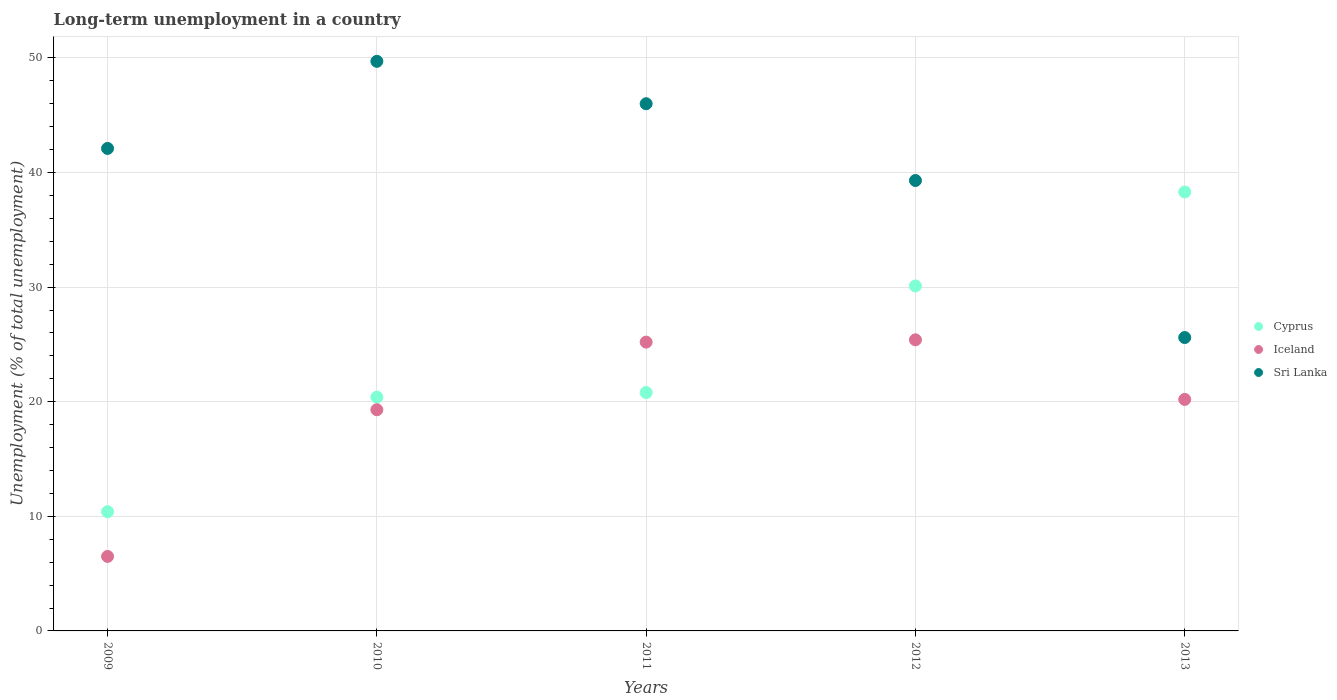What is the percentage of long-term unemployed population in Iceland in 2011?
Offer a very short reply. 25.2. Across all years, what is the maximum percentage of long-term unemployed population in Cyprus?
Make the answer very short. 38.3. Across all years, what is the minimum percentage of long-term unemployed population in Sri Lanka?
Offer a terse response. 25.6. In which year was the percentage of long-term unemployed population in Cyprus minimum?
Offer a very short reply. 2009. What is the total percentage of long-term unemployed population in Cyprus in the graph?
Keep it short and to the point. 120. What is the difference between the percentage of long-term unemployed population in Cyprus in 2010 and that in 2012?
Your answer should be very brief. -9.7. What is the difference between the percentage of long-term unemployed population in Iceland in 2011 and the percentage of long-term unemployed population in Sri Lanka in 2010?
Your answer should be compact. -24.5. What is the average percentage of long-term unemployed population in Sri Lanka per year?
Offer a very short reply. 40.54. In the year 2009, what is the difference between the percentage of long-term unemployed population in Sri Lanka and percentage of long-term unemployed population in Iceland?
Make the answer very short. 35.6. What is the ratio of the percentage of long-term unemployed population in Iceland in 2009 to that in 2012?
Offer a very short reply. 0.26. What is the difference between the highest and the second highest percentage of long-term unemployed population in Sri Lanka?
Keep it short and to the point. 3.7. What is the difference between the highest and the lowest percentage of long-term unemployed population in Sri Lanka?
Provide a succinct answer. 24.1. In how many years, is the percentage of long-term unemployed population in Cyprus greater than the average percentage of long-term unemployed population in Cyprus taken over all years?
Offer a very short reply. 2. Is it the case that in every year, the sum of the percentage of long-term unemployed population in Sri Lanka and percentage of long-term unemployed population in Iceland  is greater than the percentage of long-term unemployed population in Cyprus?
Your response must be concise. Yes. Does the percentage of long-term unemployed population in Cyprus monotonically increase over the years?
Ensure brevity in your answer.  Yes. How many dotlines are there?
Offer a terse response. 3. How many years are there in the graph?
Offer a terse response. 5. Are the values on the major ticks of Y-axis written in scientific E-notation?
Your answer should be very brief. No. Does the graph contain any zero values?
Provide a succinct answer. No. What is the title of the graph?
Your answer should be very brief. Long-term unemployment in a country. Does "Antigua and Barbuda" appear as one of the legend labels in the graph?
Provide a succinct answer. No. What is the label or title of the X-axis?
Offer a terse response. Years. What is the label or title of the Y-axis?
Ensure brevity in your answer.  Unemployment (% of total unemployment). What is the Unemployment (% of total unemployment) in Cyprus in 2009?
Offer a very short reply. 10.4. What is the Unemployment (% of total unemployment) of Sri Lanka in 2009?
Offer a very short reply. 42.1. What is the Unemployment (% of total unemployment) of Cyprus in 2010?
Ensure brevity in your answer.  20.4. What is the Unemployment (% of total unemployment) of Iceland in 2010?
Offer a terse response. 19.3. What is the Unemployment (% of total unemployment) of Sri Lanka in 2010?
Keep it short and to the point. 49.7. What is the Unemployment (% of total unemployment) in Cyprus in 2011?
Your response must be concise. 20.8. What is the Unemployment (% of total unemployment) in Iceland in 2011?
Provide a short and direct response. 25.2. What is the Unemployment (% of total unemployment) of Cyprus in 2012?
Give a very brief answer. 30.1. What is the Unemployment (% of total unemployment) of Iceland in 2012?
Keep it short and to the point. 25.4. What is the Unemployment (% of total unemployment) of Sri Lanka in 2012?
Your answer should be compact. 39.3. What is the Unemployment (% of total unemployment) of Cyprus in 2013?
Ensure brevity in your answer.  38.3. What is the Unemployment (% of total unemployment) in Iceland in 2013?
Your answer should be very brief. 20.2. What is the Unemployment (% of total unemployment) in Sri Lanka in 2013?
Your answer should be very brief. 25.6. Across all years, what is the maximum Unemployment (% of total unemployment) of Cyprus?
Ensure brevity in your answer.  38.3. Across all years, what is the maximum Unemployment (% of total unemployment) in Iceland?
Provide a short and direct response. 25.4. Across all years, what is the maximum Unemployment (% of total unemployment) in Sri Lanka?
Make the answer very short. 49.7. Across all years, what is the minimum Unemployment (% of total unemployment) of Cyprus?
Your answer should be compact. 10.4. Across all years, what is the minimum Unemployment (% of total unemployment) of Sri Lanka?
Your answer should be very brief. 25.6. What is the total Unemployment (% of total unemployment) of Cyprus in the graph?
Your response must be concise. 120. What is the total Unemployment (% of total unemployment) in Iceland in the graph?
Your answer should be compact. 96.6. What is the total Unemployment (% of total unemployment) in Sri Lanka in the graph?
Give a very brief answer. 202.7. What is the difference between the Unemployment (% of total unemployment) in Cyprus in 2009 and that in 2010?
Keep it short and to the point. -10. What is the difference between the Unemployment (% of total unemployment) of Iceland in 2009 and that in 2010?
Give a very brief answer. -12.8. What is the difference between the Unemployment (% of total unemployment) of Sri Lanka in 2009 and that in 2010?
Ensure brevity in your answer.  -7.6. What is the difference between the Unemployment (% of total unemployment) in Iceland in 2009 and that in 2011?
Your response must be concise. -18.7. What is the difference between the Unemployment (% of total unemployment) of Sri Lanka in 2009 and that in 2011?
Your answer should be very brief. -3.9. What is the difference between the Unemployment (% of total unemployment) in Cyprus in 2009 and that in 2012?
Make the answer very short. -19.7. What is the difference between the Unemployment (% of total unemployment) in Iceland in 2009 and that in 2012?
Offer a terse response. -18.9. What is the difference between the Unemployment (% of total unemployment) in Cyprus in 2009 and that in 2013?
Offer a very short reply. -27.9. What is the difference between the Unemployment (% of total unemployment) in Iceland in 2009 and that in 2013?
Offer a terse response. -13.7. What is the difference between the Unemployment (% of total unemployment) in Cyprus in 2010 and that in 2012?
Provide a succinct answer. -9.7. What is the difference between the Unemployment (% of total unemployment) in Iceland in 2010 and that in 2012?
Your response must be concise. -6.1. What is the difference between the Unemployment (% of total unemployment) of Sri Lanka in 2010 and that in 2012?
Give a very brief answer. 10.4. What is the difference between the Unemployment (% of total unemployment) in Cyprus in 2010 and that in 2013?
Keep it short and to the point. -17.9. What is the difference between the Unemployment (% of total unemployment) of Iceland in 2010 and that in 2013?
Provide a succinct answer. -0.9. What is the difference between the Unemployment (% of total unemployment) of Sri Lanka in 2010 and that in 2013?
Your answer should be compact. 24.1. What is the difference between the Unemployment (% of total unemployment) in Cyprus in 2011 and that in 2012?
Give a very brief answer. -9.3. What is the difference between the Unemployment (% of total unemployment) in Cyprus in 2011 and that in 2013?
Keep it short and to the point. -17.5. What is the difference between the Unemployment (% of total unemployment) in Iceland in 2011 and that in 2013?
Provide a short and direct response. 5. What is the difference between the Unemployment (% of total unemployment) of Sri Lanka in 2011 and that in 2013?
Your answer should be very brief. 20.4. What is the difference between the Unemployment (% of total unemployment) of Cyprus in 2012 and that in 2013?
Provide a succinct answer. -8.2. What is the difference between the Unemployment (% of total unemployment) in Iceland in 2012 and that in 2013?
Provide a short and direct response. 5.2. What is the difference between the Unemployment (% of total unemployment) of Cyprus in 2009 and the Unemployment (% of total unemployment) of Sri Lanka in 2010?
Offer a terse response. -39.3. What is the difference between the Unemployment (% of total unemployment) of Iceland in 2009 and the Unemployment (% of total unemployment) of Sri Lanka in 2010?
Provide a succinct answer. -43.2. What is the difference between the Unemployment (% of total unemployment) of Cyprus in 2009 and the Unemployment (% of total unemployment) of Iceland in 2011?
Provide a short and direct response. -14.8. What is the difference between the Unemployment (% of total unemployment) in Cyprus in 2009 and the Unemployment (% of total unemployment) in Sri Lanka in 2011?
Your response must be concise. -35.6. What is the difference between the Unemployment (% of total unemployment) in Iceland in 2009 and the Unemployment (% of total unemployment) in Sri Lanka in 2011?
Make the answer very short. -39.5. What is the difference between the Unemployment (% of total unemployment) in Cyprus in 2009 and the Unemployment (% of total unemployment) in Iceland in 2012?
Keep it short and to the point. -15. What is the difference between the Unemployment (% of total unemployment) in Cyprus in 2009 and the Unemployment (% of total unemployment) in Sri Lanka in 2012?
Your answer should be very brief. -28.9. What is the difference between the Unemployment (% of total unemployment) of Iceland in 2009 and the Unemployment (% of total unemployment) of Sri Lanka in 2012?
Make the answer very short. -32.8. What is the difference between the Unemployment (% of total unemployment) in Cyprus in 2009 and the Unemployment (% of total unemployment) in Sri Lanka in 2013?
Provide a short and direct response. -15.2. What is the difference between the Unemployment (% of total unemployment) of Iceland in 2009 and the Unemployment (% of total unemployment) of Sri Lanka in 2013?
Make the answer very short. -19.1. What is the difference between the Unemployment (% of total unemployment) in Cyprus in 2010 and the Unemployment (% of total unemployment) in Iceland in 2011?
Your answer should be very brief. -4.8. What is the difference between the Unemployment (% of total unemployment) in Cyprus in 2010 and the Unemployment (% of total unemployment) in Sri Lanka in 2011?
Your response must be concise. -25.6. What is the difference between the Unemployment (% of total unemployment) in Iceland in 2010 and the Unemployment (% of total unemployment) in Sri Lanka in 2011?
Provide a short and direct response. -26.7. What is the difference between the Unemployment (% of total unemployment) of Cyprus in 2010 and the Unemployment (% of total unemployment) of Sri Lanka in 2012?
Your answer should be compact. -18.9. What is the difference between the Unemployment (% of total unemployment) in Iceland in 2010 and the Unemployment (% of total unemployment) in Sri Lanka in 2012?
Keep it short and to the point. -20. What is the difference between the Unemployment (% of total unemployment) in Cyprus in 2011 and the Unemployment (% of total unemployment) in Sri Lanka in 2012?
Give a very brief answer. -18.5. What is the difference between the Unemployment (% of total unemployment) in Iceland in 2011 and the Unemployment (% of total unemployment) in Sri Lanka in 2012?
Make the answer very short. -14.1. What is the difference between the Unemployment (% of total unemployment) of Cyprus in 2011 and the Unemployment (% of total unemployment) of Sri Lanka in 2013?
Your response must be concise. -4.8. What is the average Unemployment (% of total unemployment) of Iceland per year?
Your response must be concise. 19.32. What is the average Unemployment (% of total unemployment) in Sri Lanka per year?
Provide a succinct answer. 40.54. In the year 2009, what is the difference between the Unemployment (% of total unemployment) of Cyprus and Unemployment (% of total unemployment) of Sri Lanka?
Your answer should be very brief. -31.7. In the year 2009, what is the difference between the Unemployment (% of total unemployment) in Iceland and Unemployment (% of total unemployment) in Sri Lanka?
Ensure brevity in your answer.  -35.6. In the year 2010, what is the difference between the Unemployment (% of total unemployment) in Cyprus and Unemployment (% of total unemployment) in Sri Lanka?
Offer a very short reply. -29.3. In the year 2010, what is the difference between the Unemployment (% of total unemployment) in Iceland and Unemployment (% of total unemployment) in Sri Lanka?
Ensure brevity in your answer.  -30.4. In the year 2011, what is the difference between the Unemployment (% of total unemployment) in Cyprus and Unemployment (% of total unemployment) in Iceland?
Offer a terse response. -4.4. In the year 2011, what is the difference between the Unemployment (% of total unemployment) in Cyprus and Unemployment (% of total unemployment) in Sri Lanka?
Provide a short and direct response. -25.2. In the year 2011, what is the difference between the Unemployment (% of total unemployment) in Iceland and Unemployment (% of total unemployment) in Sri Lanka?
Your answer should be very brief. -20.8. In the year 2012, what is the difference between the Unemployment (% of total unemployment) in Cyprus and Unemployment (% of total unemployment) in Iceland?
Give a very brief answer. 4.7. In the year 2012, what is the difference between the Unemployment (% of total unemployment) of Cyprus and Unemployment (% of total unemployment) of Sri Lanka?
Your response must be concise. -9.2. In the year 2012, what is the difference between the Unemployment (% of total unemployment) of Iceland and Unemployment (% of total unemployment) of Sri Lanka?
Offer a very short reply. -13.9. In the year 2013, what is the difference between the Unemployment (% of total unemployment) of Cyprus and Unemployment (% of total unemployment) of Sri Lanka?
Offer a very short reply. 12.7. In the year 2013, what is the difference between the Unemployment (% of total unemployment) in Iceland and Unemployment (% of total unemployment) in Sri Lanka?
Make the answer very short. -5.4. What is the ratio of the Unemployment (% of total unemployment) of Cyprus in 2009 to that in 2010?
Give a very brief answer. 0.51. What is the ratio of the Unemployment (% of total unemployment) of Iceland in 2009 to that in 2010?
Give a very brief answer. 0.34. What is the ratio of the Unemployment (% of total unemployment) in Sri Lanka in 2009 to that in 2010?
Keep it short and to the point. 0.85. What is the ratio of the Unemployment (% of total unemployment) of Iceland in 2009 to that in 2011?
Your answer should be compact. 0.26. What is the ratio of the Unemployment (% of total unemployment) of Sri Lanka in 2009 to that in 2011?
Keep it short and to the point. 0.92. What is the ratio of the Unemployment (% of total unemployment) in Cyprus in 2009 to that in 2012?
Your answer should be very brief. 0.35. What is the ratio of the Unemployment (% of total unemployment) of Iceland in 2009 to that in 2012?
Provide a succinct answer. 0.26. What is the ratio of the Unemployment (% of total unemployment) of Sri Lanka in 2009 to that in 2012?
Keep it short and to the point. 1.07. What is the ratio of the Unemployment (% of total unemployment) in Cyprus in 2009 to that in 2013?
Keep it short and to the point. 0.27. What is the ratio of the Unemployment (% of total unemployment) of Iceland in 2009 to that in 2013?
Ensure brevity in your answer.  0.32. What is the ratio of the Unemployment (% of total unemployment) of Sri Lanka in 2009 to that in 2013?
Provide a succinct answer. 1.64. What is the ratio of the Unemployment (% of total unemployment) in Cyprus in 2010 to that in 2011?
Ensure brevity in your answer.  0.98. What is the ratio of the Unemployment (% of total unemployment) in Iceland in 2010 to that in 2011?
Your answer should be compact. 0.77. What is the ratio of the Unemployment (% of total unemployment) in Sri Lanka in 2010 to that in 2011?
Provide a succinct answer. 1.08. What is the ratio of the Unemployment (% of total unemployment) of Cyprus in 2010 to that in 2012?
Provide a short and direct response. 0.68. What is the ratio of the Unemployment (% of total unemployment) in Iceland in 2010 to that in 2012?
Give a very brief answer. 0.76. What is the ratio of the Unemployment (% of total unemployment) of Sri Lanka in 2010 to that in 2012?
Make the answer very short. 1.26. What is the ratio of the Unemployment (% of total unemployment) in Cyprus in 2010 to that in 2013?
Your response must be concise. 0.53. What is the ratio of the Unemployment (% of total unemployment) in Iceland in 2010 to that in 2013?
Offer a very short reply. 0.96. What is the ratio of the Unemployment (% of total unemployment) in Sri Lanka in 2010 to that in 2013?
Ensure brevity in your answer.  1.94. What is the ratio of the Unemployment (% of total unemployment) in Cyprus in 2011 to that in 2012?
Provide a succinct answer. 0.69. What is the ratio of the Unemployment (% of total unemployment) in Sri Lanka in 2011 to that in 2012?
Offer a terse response. 1.17. What is the ratio of the Unemployment (% of total unemployment) in Cyprus in 2011 to that in 2013?
Provide a succinct answer. 0.54. What is the ratio of the Unemployment (% of total unemployment) in Iceland in 2011 to that in 2013?
Make the answer very short. 1.25. What is the ratio of the Unemployment (% of total unemployment) in Sri Lanka in 2011 to that in 2013?
Your answer should be very brief. 1.8. What is the ratio of the Unemployment (% of total unemployment) of Cyprus in 2012 to that in 2013?
Offer a terse response. 0.79. What is the ratio of the Unemployment (% of total unemployment) of Iceland in 2012 to that in 2013?
Your response must be concise. 1.26. What is the ratio of the Unemployment (% of total unemployment) in Sri Lanka in 2012 to that in 2013?
Ensure brevity in your answer.  1.54. What is the difference between the highest and the second highest Unemployment (% of total unemployment) in Cyprus?
Ensure brevity in your answer.  8.2. What is the difference between the highest and the lowest Unemployment (% of total unemployment) of Cyprus?
Provide a short and direct response. 27.9. What is the difference between the highest and the lowest Unemployment (% of total unemployment) of Iceland?
Offer a very short reply. 18.9. What is the difference between the highest and the lowest Unemployment (% of total unemployment) of Sri Lanka?
Your answer should be very brief. 24.1. 